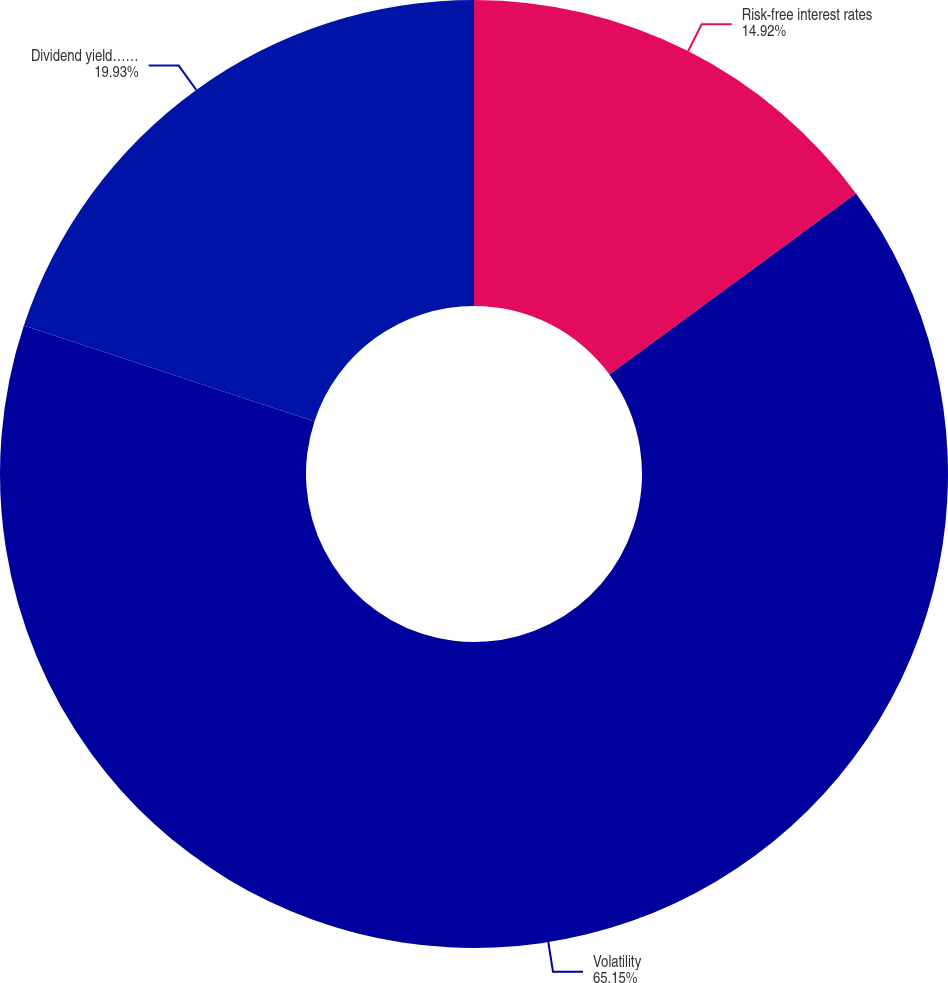<chart> <loc_0><loc_0><loc_500><loc_500><pie_chart><fcel>Risk-free interest rates<fcel>Volatility<fcel>Dividend yield……<nl><fcel>14.92%<fcel>65.15%<fcel>19.93%<nl></chart> 